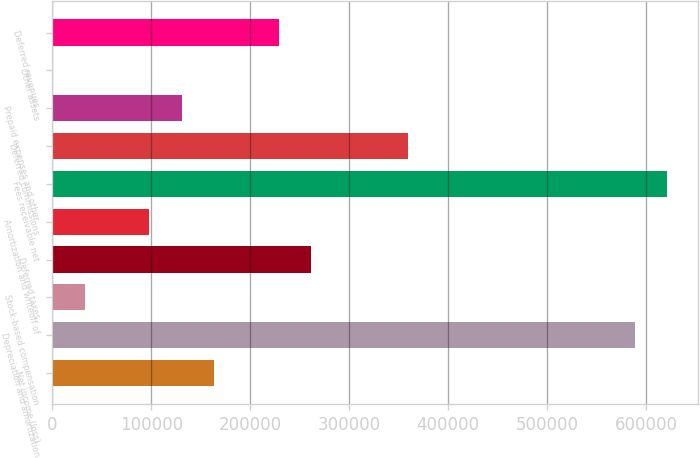Convert chart. <chart><loc_0><loc_0><loc_500><loc_500><bar_chart><fcel>Net income (loss)<fcel>Depreciation and amortization<fcel>Stock-based compensation<fcel>Deferred taxes<fcel>Amortization and writeoff of<fcel>Fees receivable net<fcel>Deferred commissions<fcel>Prepaid expenses and other<fcel>Other assets<fcel>Deferred revenues<nl><fcel>163556<fcel>588510<fcel>32801.7<fcel>261623<fcel>98179.1<fcel>621198<fcel>359689<fcel>130868<fcel>113<fcel>228934<nl></chart> 